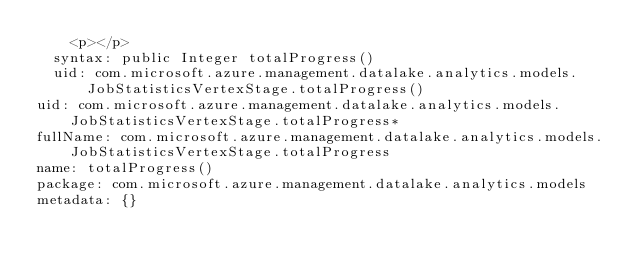Convert code to text. <code><loc_0><loc_0><loc_500><loc_500><_YAML_>    <p></p>
  syntax: public Integer totalProgress()
  uid: com.microsoft.azure.management.datalake.analytics.models.JobStatisticsVertexStage.totalProgress()
uid: com.microsoft.azure.management.datalake.analytics.models.JobStatisticsVertexStage.totalProgress*
fullName: com.microsoft.azure.management.datalake.analytics.models.JobStatisticsVertexStage.totalProgress
name: totalProgress()
package: com.microsoft.azure.management.datalake.analytics.models
metadata: {}
</code> 